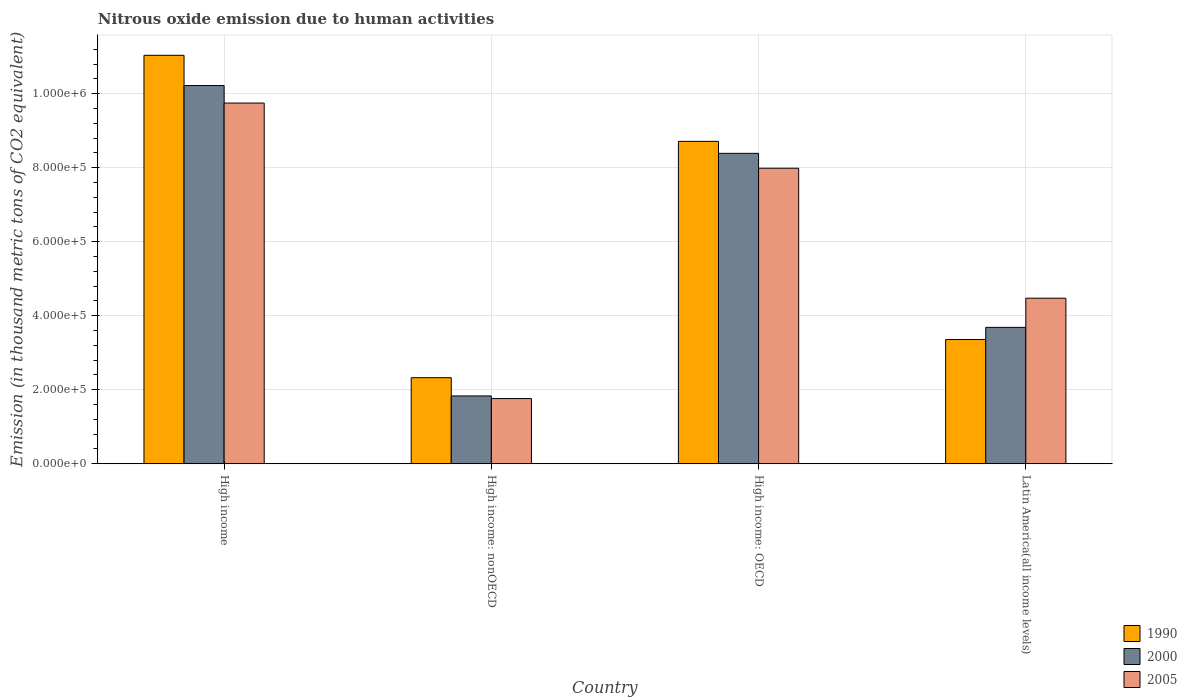How many different coloured bars are there?
Offer a very short reply. 3. Are the number of bars per tick equal to the number of legend labels?
Your response must be concise. Yes. What is the label of the 4th group of bars from the left?
Offer a very short reply. Latin America(all income levels). What is the amount of nitrous oxide emitted in 1990 in High income?
Make the answer very short. 1.10e+06. Across all countries, what is the maximum amount of nitrous oxide emitted in 2005?
Offer a terse response. 9.74e+05. Across all countries, what is the minimum amount of nitrous oxide emitted in 1990?
Your answer should be very brief. 2.33e+05. In which country was the amount of nitrous oxide emitted in 1990 maximum?
Provide a short and direct response. High income. In which country was the amount of nitrous oxide emitted in 2005 minimum?
Give a very brief answer. High income: nonOECD. What is the total amount of nitrous oxide emitted in 2005 in the graph?
Offer a terse response. 2.40e+06. What is the difference between the amount of nitrous oxide emitted in 2005 in High income and that in High income: nonOECD?
Your answer should be compact. 7.98e+05. What is the difference between the amount of nitrous oxide emitted in 2000 in High income and the amount of nitrous oxide emitted in 2005 in High income: nonOECD?
Make the answer very short. 8.46e+05. What is the average amount of nitrous oxide emitted in 2005 per country?
Give a very brief answer. 5.99e+05. What is the difference between the amount of nitrous oxide emitted of/in 2000 and amount of nitrous oxide emitted of/in 1990 in Latin America(all income levels)?
Ensure brevity in your answer.  3.29e+04. What is the ratio of the amount of nitrous oxide emitted in 2000 in High income to that in Latin America(all income levels)?
Give a very brief answer. 2.77. Is the amount of nitrous oxide emitted in 2000 in High income: OECD less than that in High income: nonOECD?
Offer a terse response. No. What is the difference between the highest and the second highest amount of nitrous oxide emitted in 2005?
Provide a succinct answer. -1.76e+05. What is the difference between the highest and the lowest amount of nitrous oxide emitted in 2000?
Offer a very short reply. 8.39e+05. In how many countries, is the amount of nitrous oxide emitted in 1990 greater than the average amount of nitrous oxide emitted in 1990 taken over all countries?
Offer a very short reply. 2. What does the 2nd bar from the left in High income: OECD represents?
Offer a very short reply. 2000. What does the 2nd bar from the right in Latin America(all income levels) represents?
Give a very brief answer. 2000. Is it the case that in every country, the sum of the amount of nitrous oxide emitted in 2005 and amount of nitrous oxide emitted in 2000 is greater than the amount of nitrous oxide emitted in 1990?
Your answer should be compact. Yes. How many bars are there?
Your answer should be compact. 12. How many countries are there in the graph?
Provide a succinct answer. 4. Does the graph contain any zero values?
Provide a short and direct response. No. Does the graph contain grids?
Offer a very short reply. Yes. Where does the legend appear in the graph?
Offer a terse response. Bottom right. What is the title of the graph?
Offer a very short reply. Nitrous oxide emission due to human activities. Does "1995" appear as one of the legend labels in the graph?
Your response must be concise. No. What is the label or title of the X-axis?
Your response must be concise. Country. What is the label or title of the Y-axis?
Offer a terse response. Emission (in thousand metric tons of CO2 equivalent). What is the Emission (in thousand metric tons of CO2 equivalent) of 1990 in High income?
Make the answer very short. 1.10e+06. What is the Emission (in thousand metric tons of CO2 equivalent) in 2000 in High income?
Provide a short and direct response. 1.02e+06. What is the Emission (in thousand metric tons of CO2 equivalent) in 2005 in High income?
Make the answer very short. 9.74e+05. What is the Emission (in thousand metric tons of CO2 equivalent) of 1990 in High income: nonOECD?
Provide a short and direct response. 2.33e+05. What is the Emission (in thousand metric tons of CO2 equivalent) of 2000 in High income: nonOECD?
Ensure brevity in your answer.  1.83e+05. What is the Emission (in thousand metric tons of CO2 equivalent) in 2005 in High income: nonOECD?
Keep it short and to the point. 1.76e+05. What is the Emission (in thousand metric tons of CO2 equivalent) of 1990 in High income: OECD?
Provide a short and direct response. 8.71e+05. What is the Emission (in thousand metric tons of CO2 equivalent) in 2000 in High income: OECD?
Your answer should be compact. 8.39e+05. What is the Emission (in thousand metric tons of CO2 equivalent) of 2005 in High income: OECD?
Your answer should be very brief. 7.98e+05. What is the Emission (in thousand metric tons of CO2 equivalent) of 1990 in Latin America(all income levels)?
Your answer should be compact. 3.36e+05. What is the Emission (in thousand metric tons of CO2 equivalent) in 2000 in Latin America(all income levels)?
Make the answer very short. 3.68e+05. What is the Emission (in thousand metric tons of CO2 equivalent) in 2005 in Latin America(all income levels)?
Your response must be concise. 4.47e+05. Across all countries, what is the maximum Emission (in thousand metric tons of CO2 equivalent) of 1990?
Your answer should be very brief. 1.10e+06. Across all countries, what is the maximum Emission (in thousand metric tons of CO2 equivalent) of 2000?
Make the answer very short. 1.02e+06. Across all countries, what is the maximum Emission (in thousand metric tons of CO2 equivalent) of 2005?
Your answer should be very brief. 9.74e+05. Across all countries, what is the minimum Emission (in thousand metric tons of CO2 equivalent) in 1990?
Your answer should be very brief. 2.33e+05. Across all countries, what is the minimum Emission (in thousand metric tons of CO2 equivalent) in 2000?
Give a very brief answer. 1.83e+05. Across all countries, what is the minimum Emission (in thousand metric tons of CO2 equivalent) in 2005?
Ensure brevity in your answer.  1.76e+05. What is the total Emission (in thousand metric tons of CO2 equivalent) of 1990 in the graph?
Give a very brief answer. 2.54e+06. What is the total Emission (in thousand metric tons of CO2 equivalent) of 2000 in the graph?
Your response must be concise. 2.41e+06. What is the total Emission (in thousand metric tons of CO2 equivalent) of 2005 in the graph?
Your answer should be compact. 2.40e+06. What is the difference between the Emission (in thousand metric tons of CO2 equivalent) in 1990 in High income and that in High income: nonOECD?
Your answer should be compact. 8.71e+05. What is the difference between the Emission (in thousand metric tons of CO2 equivalent) of 2000 in High income and that in High income: nonOECD?
Give a very brief answer. 8.39e+05. What is the difference between the Emission (in thousand metric tons of CO2 equivalent) in 2005 in High income and that in High income: nonOECD?
Make the answer very short. 7.98e+05. What is the difference between the Emission (in thousand metric tons of CO2 equivalent) of 1990 in High income and that in High income: OECD?
Provide a succinct answer. 2.33e+05. What is the difference between the Emission (in thousand metric tons of CO2 equivalent) of 2000 in High income and that in High income: OECD?
Offer a very short reply. 1.83e+05. What is the difference between the Emission (in thousand metric tons of CO2 equivalent) of 2005 in High income and that in High income: OECD?
Offer a very short reply. 1.76e+05. What is the difference between the Emission (in thousand metric tons of CO2 equivalent) of 1990 in High income and that in Latin America(all income levels)?
Provide a succinct answer. 7.68e+05. What is the difference between the Emission (in thousand metric tons of CO2 equivalent) of 2000 in High income and that in Latin America(all income levels)?
Offer a very short reply. 6.53e+05. What is the difference between the Emission (in thousand metric tons of CO2 equivalent) in 2005 in High income and that in Latin America(all income levels)?
Ensure brevity in your answer.  5.27e+05. What is the difference between the Emission (in thousand metric tons of CO2 equivalent) in 1990 in High income: nonOECD and that in High income: OECD?
Offer a very short reply. -6.38e+05. What is the difference between the Emission (in thousand metric tons of CO2 equivalent) of 2000 in High income: nonOECD and that in High income: OECD?
Provide a short and direct response. -6.55e+05. What is the difference between the Emission (in thousand metric tons of CO2 equivalent) of 2005 in High income: nonOECD and that in High income: OECD?
Your answer should be compact. -6.22e+05. What is the difference between the Emission (in thousand metric tons of CO2 equivalent) of 1990 in High income: nonOECD and that in Latin America(all income levels)?
Ensure brevity in your answer.  -1.03e+05. What is the difference between the Emission (in thousand metric tons of CO2 equivalent) of 2000 in High income: nonOECD and that in Latin America(all income levels)?
Offer a terse response. -1.85e+05. What is the difference between the Emission (in thousand metric tons of CO2 equivalent) in 2005 in High income: nonOECD and that in Latin America(all income levels)?
Ensure brevity in your answer.  -2.71e+05. What is the difference between the Emission (in thousand metric tons of CO2 equivalent) of 1990 in High income: OECD and that in Latin America(all income levels)?
Offer a very short reply. 5.35e+05. What is the difference between the Emission (in thousand metric tons of CO2 equivalent) in 2000 in High income: OECD and that in Latin America(all income levels)?
Offer a very short reply. 4.70e+05. What is the difference between the Emission (in thousand metric tons of CO2 equivalent) in 2005 in High income: OECD and that in Latin America(all income levels)?
Your answer should be compact. 3.51e+05. What is the difference between the Emission (in thousand metric tons of CO2 equivalent) in 1990 in High income and the Emission (in thousand metric tons of CO2 equivalent) in 2000 in High income: nonOECD?
Offer a terse response. 9.20e+05. What is the difference between the Emission (in thousand metric tons of CO2 equivalent) of 1990 in High income and the Emission (in thousand metric tons of CO2 equivalent) of 2005 in High income: nonOECD?
Give a very brief answer. 9.27e+05. What is the difference between the Emission (in thousand metric tons of CO2 equivalent) in 2000 in High income and the Emission (in thousand metric tons of CO2 equivalent) in 2005 in High income: nonOECD?
Your response must be concise. 8.46e+05. What is the difference between the Emission (in thousand metric tons of CO2 equivalent) of 1990 in High income and the Emission (in thousand metric tons of CO2 equivalent) of 2000 in High income: OECD?
Your answer should be compact. 2.65e+05. What is the difference between the Emission (in thousand metric tons of CO2 equivalent) in 1990 in High income and the Emission (in thousand metric tons of CO2 equivalent) in 2005 in High income: OECD?
Provide a succinct answer. 3.05e+05. What is the difference between the Emission (in thousand metric tons of CO2 equivalent) of 2000 in High income and the Emission (in thousand metric tons of CO2 equivalent) of 2005 in High income: OECD?
Offer a very short reply. 2.23e+05. What is the difference between the Emission (in thousand metric tons of CO2 equivalent) in 1990 in High income and the Emission (in thousand metric tons of CO2 equivalent) in 2000 in Latin America(all income levels)?
Provide a succinct answer. 7.35e+05. What is the difference between the Emission (in thousand metric tons of CO2 equivalent) in 1990 in High income and the Emission (in thousand metric tons of CO2 equivalent) in 2005 in Latin America(all income levels)?
Your answer should be compact. 6.56e+05. What is the difference between the Emission (in thousand metric tons of CO2 equivalent) of 2000 in High income and the Emission (in thousand metric tons of CO2 equivalent) of 2005 in Latin America(all income levels)?
Offer a very short reply. 5.75e+05. What is the difference between the Emission (in thousand metric tons of CO2 equivalent) of 1990 in High income: nonOECD and the Emission (in thousand metric tons of CO2 equivalent) of 2000 in High income: OECD?
Ensure brevity in your answer.  -6.06e+05. What is the difference between the Emission (in thousand metric tons of CO2 equivalent) of 1990 in High income: nonOECD and the Emission (in thousand metric tons of CO2 equivalent) of 2005 in High income: OECD?
Your answer should be compact. -5.66e+05. What is the difference between the Emission (in thousand metric tons of CO2 equivalent) in 2000 in High income: nonOECD and the Emission (in thousand metric tons of CO2 equivalent) in 2005 in High income: OECD?
Ensure brevity in your answer.  -6.15e+05. What is the difference between the Emission (in thousand metric tons of CO2 equivalent) of 1990 in High income: nonOECD and the Emission (in thousand metric tons of CO2 equivalent) of 2000 in Latin America(all income levels)?
Ensure brevity in your answer.  -1.36e+05. What is the difference between the Emission (in thousand metric tons of CO2 equivalent) of 1990 in High income: nonOECD and the Emission (in thousand metric tons of CO2 equivalent) of 2005 in Latin America(all income levels)?
Give a very brief answer. -2.15e+05. What is the difference between the Emission (in thousand metric tons of CO2 equivalent) of 2000 in High income: nonOECD and the Emission (in thousand metric tons of CO2 equivalent) of 2005 in Latin America(all income levels)?
Your answer should be compact. -2.64e+05. What is the difference between the Emission (in thousand metric tons of CO2 equivalent) of 1990 in High income: OECD and the Emission (in thousand metric tons of CO2 equivalent) of 2000 in Latin America(all income levels)?
Provide a succinct answer. 5.03e+05. What is the difference between the Emission (in thousand metric tons of CO2 equivalent) of 1990 in High income: OECD and the Emission (in thousand metric tons of CO2 equivalent) of 2005 in Latin America(all income levels)?
Keep it short and to the point. 4.24e+05. What is the difference between the Emission (in thousand metric tons of CO2 equivalent) of 2000 in High income: OECD and the Emission (in thousand metric tons of CO2 equivalent) of 2005 in Latin America(all income levels)?
Offer a terse response. 3.91e+05. What is the average Emission (in thousand metric tons of CO2 equivalent) in 1990 per country?
Your answer should be very brief. 6.36e+05. What is the average Emission (in thousand metric tons of CO2 equivalent) in 2000 per country?
Keep it short and to the point. 6.03e+05. What is the average Emission (in thousand metric tons of CO2 equivalent) of 2005 per country?
Your answer should be very brief. 5.99e+05. What is the difference between the Emission (in thousand metric tons of CO2 equivalent) in 1990 and Emission (in thousand metric tons of CO2 equivalent) in 2000 in High income?
Make the answer very short. 8.17e+04. What is the difference between the Emission (in thousand metric tons of CO2 equivalent) of 1990 and Emission (in thousand metric tons of CO2 equivalent) of 2005 in High income?
Give a very brief answer. 1.29e+05. What is the difference between the Emission (in thousand metric tons of CO2 equivalent) in 2000 and Emission (in thousand metric tons of CO2 equivalent) in 2005 in High income?
Keep it short and to the point. 4.74e+04. What is the difference between the Emission (in thousand metric tons of CO2 equivalent) of 1990 and Emission (in thousand metric tons of CO2 equivalent) of 2000 in High income: nonOECD?
Your answer should be very brief. 4.94e+04. What is the difference between the Emission (in thousand metric tons of CO2 equivalent) in 1990 and Emission (in thousand metric tons of CO2 equivalent) in 2005 in High income: nonOECD?
Your answer should be very brief. 5.65e+04. What is the difference between the Emission (in thousand metric tons of CO2 equivalent) in 2000 and Emission (in thousand metric tons of CO2 equivalent) in 2005 in High income: nonOECD?
Make the answer very short. 7109.4. What is the difference between the Emission (in thousand metric tons of CO2 equivalent) of 1990 and Emission (in thousand metric tons of CO2 equivalent) of 2000 in High income: OECD?
Offer a terse response. 3.24e+04. What is the difference between the Emission (in thousand metric tons of CO2 equivalent) of 1990 and Emission (in thousand metric tons of CO2 equivalent) of 2005 in High income: OECD?
Ensure brevity in your answer.  7.26e+04. What is the difference between the Emission (in thousand metric tons of CO2 equivalent) of 2000 and Emission (in thousand metric tons of CO2 equivalent) of 2005 in High income: OECD?
Your answer should be very brief. 4.02e+04. What is the difference between the Emission (in thousand metric tons of CO2 equivalent) of 1990 and Emission (in thousand metric tons of CO2 equivalent) of 2000 in Latin America(all income levels)?
Your answer should be compact. -3.29e+04. What is the difference between the Emission (in thousand metric tons of CO2 equivalent) in 1990 and Emission (in thousand metric tons of CO2 equivalent) in 2005 in Latin America(all income levels)?
Give a very brief answer. -1.12e+05. What is the difference between the Emission (in thousand metric tons of CO2 equivalent) in 2000 and Emission (in thousand metric tons of CO2 equivalent) in 2005 in Latin America(all income levels)?
Keep it short and to the point. -7.88e+04. What is the ratio of the Emission (in thousand metric tons of CO2 equivalent) in 1990 in High income to that in High income: nonOECD?
Keep it short and to the point. 4.75. What is the ratio of the Emission (in thousand metric tons of CO2 equivalent) in 2000 in High income to that in High income: nonOECD?
Your response must be concise. 5.58. What is the ratio of the Emission (in thousand metric tons of CO2 equivalent) in 2005 in High income to that in High income: nonOECD?
Make the answer very short. 5.54. What is the ratio of the Emission (in thousand metric tons of CO2 equivalent) of 1990 in High income to that in High income: OECD?
Give a very brief answer. 1.27. What is the ratio of the Emission (in thousand metric tons of CO2 equivalent) in 2000 in High income to that in High income: OECD?
Offer a very short reply. 1.22. What is the ratio of the Emission (in thousand metric tons of CO2 equivalent) of 2005 in High income to that in High income: OECD?
Provide a succinct answer. 1.22. What is the ratio of the Emission (in thousand metric tons of CO2 equivalent) in 1990 in High income to that in Latin America(all income levels)?
Make the answer very short. 3.29. What is the ratio of the Emission (in thousand metric tons of CO2 equivalent) in 2000 in High income to that in Latin America(all income levels)?
Provide a short and direct response. 2.77. What is the ratio of the Emission (in thousand metric tons of CO2 equivalent) of 2005 in High income to that in Latin America(all income levels)?
Offer a terse response. 2.18. What is the ratio of the Emission (in thousand metric tons of CO2 equivalent) in 1990 in High income: nonOECD to that in High income: OECD?
Offer a terse response. 0.27. What is the ratio of the Emission (in thousand metric tons of CO2 equivalent) in 2000 in High income: nonOECD to that in High income: OECD?
Offer a terse response. 0.22. What is the ratio of the Emission (in thousand metric tons of CO2 equivalent) of 2005 in High income: nonOECD to that in High income: OECD?
Offer a terse response. 0.22. What is the ratio of the Emission (in thousand metric tons of CO2 equivalent) of 1990 in High income: nonOECD to that in Latin America(all income levels)?
Provide a short and direct response. 0.69. What is the ratio of the Emission (in thousand metric tons of CO2 equivalent) of 2000 in High income: nonOECD to that in Latin America(all income levels)?
Make the answer very short. 0.5. What is the ratio of the Emission (in thousand metric tons of CO2 equivalent) of 2005 in High income: nonOECD to that in Latin America(all income levels)?
Make the answer very short. 0.39. What is the ratio of the Emission (in thousand metric tons of CO2 equivalent) in 1990 in High income: OECD to that in Latin America(all income levels)?
Your answer should be very brief. 2.6. What is the ratio of the Emission (in thousand metric tons of CO2 equivalent) of 2000 in High income: OECD to that in Latin America(all income levels)?
Keep it short and to the point. 2.28. What is the ratio of the Emission (in thousand metric tons of CO2 equivalent) of 2005 in High income: OECD to that in Latin America(all income levels)?
Provide a short and direct response. 1.78. What is the difference between the highest and the second highest Emission (in thousand metric tons of CO2 equivalent) in 1990?
Keep it short and to the point. 2.33e+05. What is the difference between the highest and the second highest Emission (in thousand metric tons of CO2 equivalent) in 2000?
Ensure brevity in your answer.  1.83e+05. What is the difference between the highest and the second highest Emission (in thousand metric tons of CO2 equivalent) of 2005?
Ensure brevity in your answer.  1.76e+05. What is the difference between the highest and the lowest Emission (in thousand metric tons of CO2 equivalent) in 1990?
Provide a succinct answer. 8.71e+05. What is the difference between the highest and the lowest Emission (in thousand metric tons of CO2 equivalent) in 2000?
Provide a short and direct response. 8.39e+05. What is the difference between the highest and the lowest Emission (in thousand metric tons of CO2 equivalent) of 2005?
Make the answer very short. 7.98e+05. 